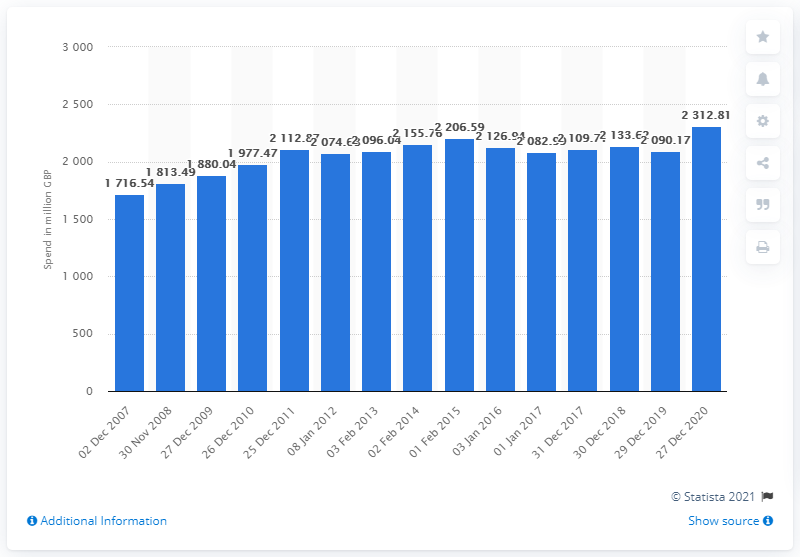Outline some significant characteristics in this image. Over a period of 13 years from December 2007 to December 2020, a total of 2312.81 dollars was spent on sliced cooked meats. 